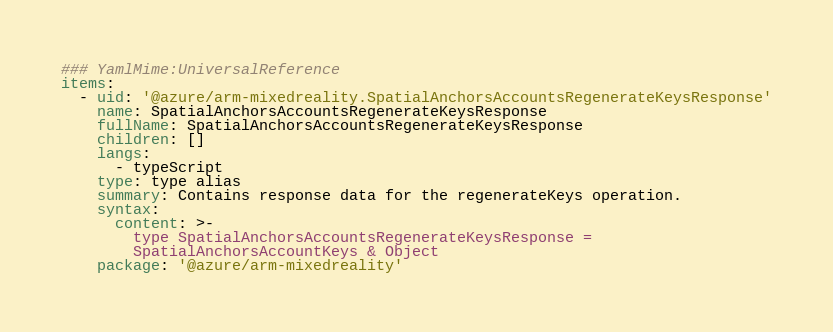<code> <loc_0><loc_0><loc_500><loc_500><_YAML_>### YamlMime:UniversalReference
items:
  - uid: '@azure/arm-mixedreality.SpatialAnchorsAccountsRegenerateKeysResponse'
    name: SpatialAnchorsAccountsRegenerateKeysResponse
    fullName: SpatialAnchorsAccountsRegenerateKeysResponse
    children: []
    langs:
      - typeScript
    type: type alias
    summary: Contains response data for the regenerateKeys operation.
    syntax:
      content: >-
        type SpatialAnchorsAccountsRegenerateKeysResponse =
        SpatialAnchorsAccountKeys & Object
    package: '@azure/arm-mixedreality'
</code> 